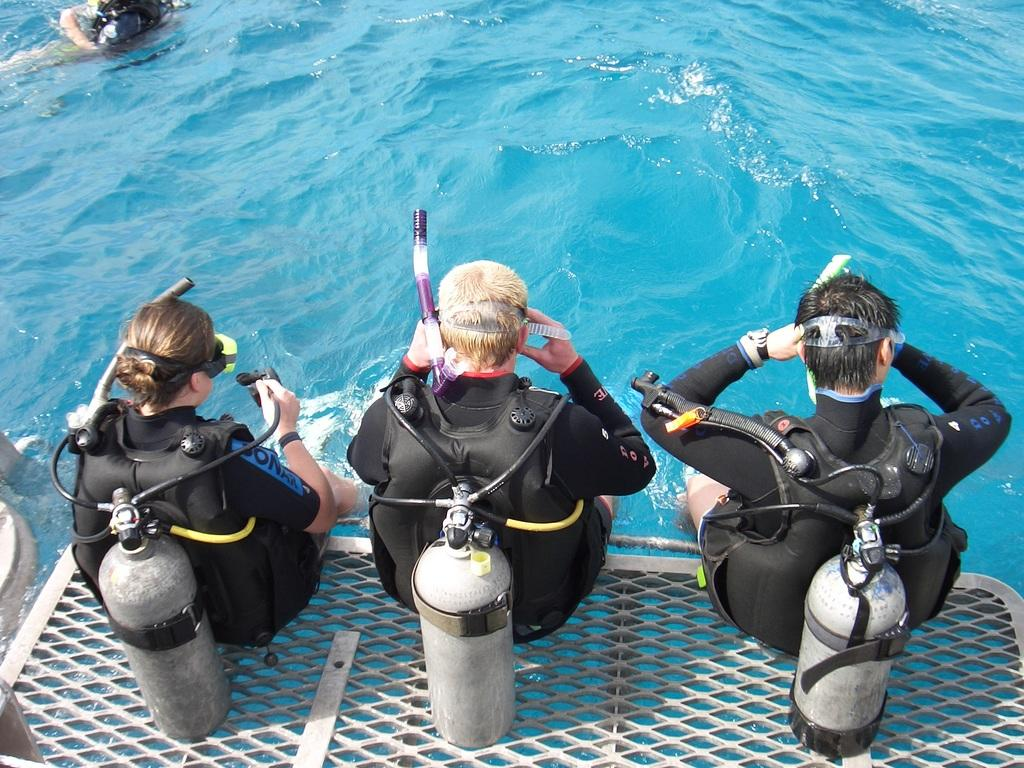What is the main setting of the image? There is a sea in the image. What is the person in the water doing? The person is in the water. What can be seen on the surface of the water? There are objects on the surface of the water. How many people are in the ship, and what are they doing? There are three people sitting in a ship, and they are holding objects. Where is the meeting taking place in the image? There is no meeting present in the image; it features a sea, a person in the water, objects on the surface, and people in a ship. Can you see any blood in the image? There is no blood visible in the image. 